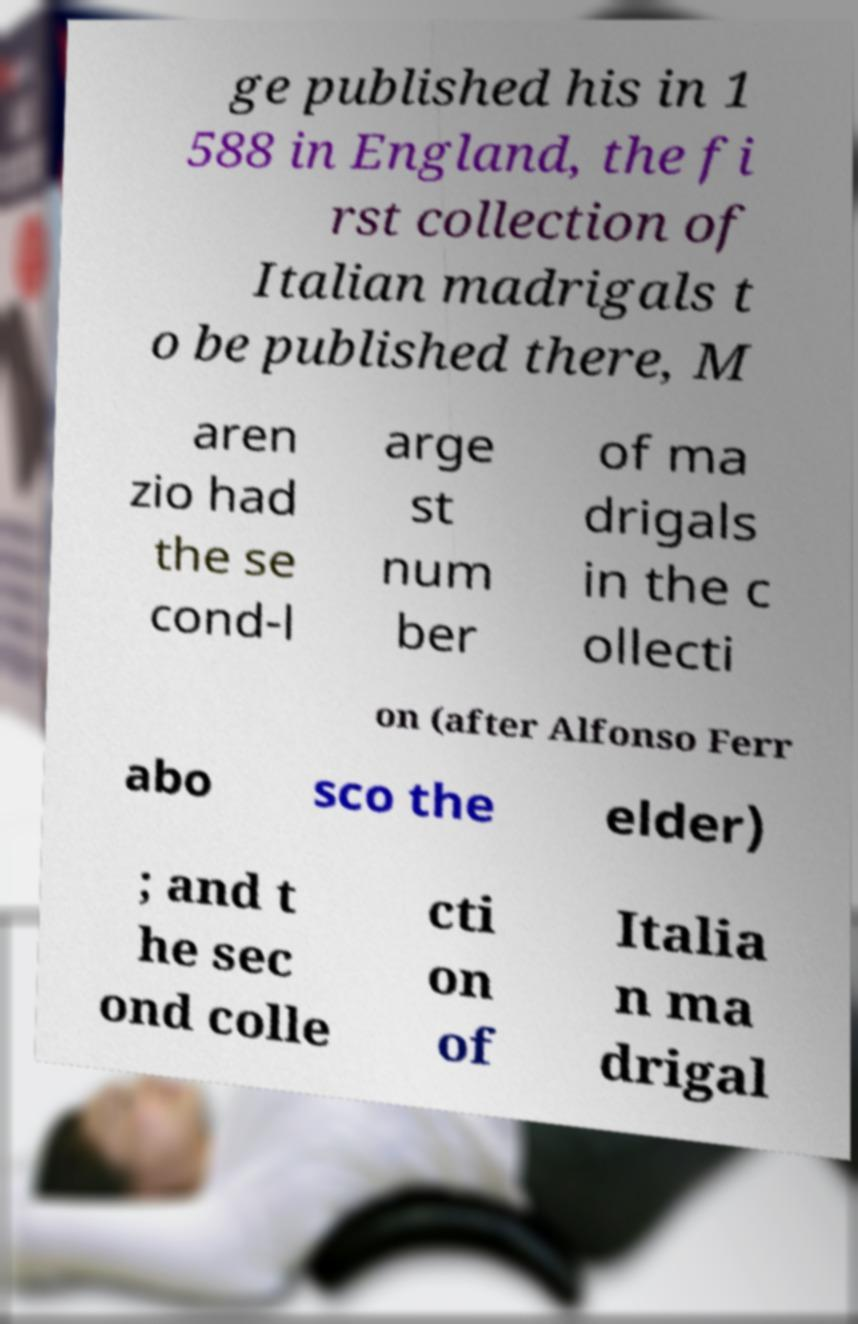For documentation purposes, I need the text within this image transcribed. Could you provide that? ge published his in 1 588 in England, the fi rst collection of Italian madrigals t o be published there, M aren zio had the se cond-l arge st num ber of ma drigals in the c ollecti on (after Alfonso Ferr abo sco the elder) ; and t he sec ond colle cti on of Italia n ma drigal 